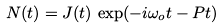<formula> <loc_0><loc_0><loc_500><loc_500>N ( t ) = J ( t ) \, \exp ( - i \omega _ { o } t - P t )</formula> 